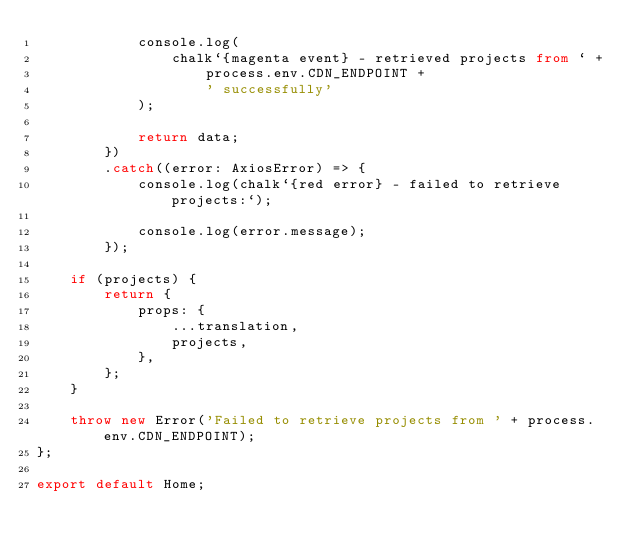Convert code to text. <code><loc_0><loc_0><loc_500><loc_500><_TypeScript_>			console.log(
				chalk`{magenta event} - retrieved projects from ` +
					process.env.CDN_ENDPOINT +
					' successfully'
			);

			return data;
		})
		.catch((error: AxiosError) => {
			console.log(chalk`{red error} - failed to retrieve projects:`);

			console.log(error.message);
		});

	if (projects) {
		return {
			props: {
				...translation,
				projects,
			},
		};
	}

	throw new Error('Failed to retrieve projects from ' + process.env.CDN_ENDPOINT);
};

export default Home;
</code> 